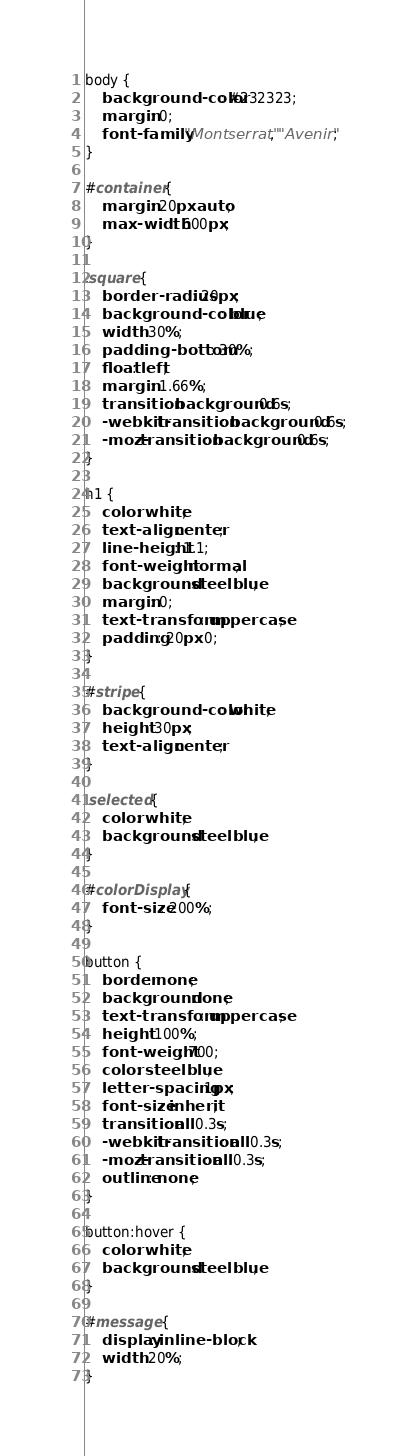Convert code to text. <code><loc_0><loc_0><loc_500><loc_500><_CSS_>body {
    background-color: #232323;
    margin: 0;
    font-family: "Montserrat", "Avenir";
}

#container {
    margin: 20px auto;
    max-width: 600px;
}

.square {
    border-radius: 20px;
    background-color: blue;
    width: 30%;
    padding-bottom: 30%;
    float: left;
    margin: 1.66%;
    transition: background 0.6s;
    -webkit-transition: background 0.6s;
    -moz-transition: background 0.6s;
}

h1 {
    color: white;
    text-align: center;
    line-height: 1.1;
    font-weight: normal;
    background: steelblue;
    margin: 0;
    text-transform: uppercase;
    padding: 20px 0;
}

#stripe {
    background-color: white;
    height: 30px;
    text-align: center;
}

.selected {
    color: white;
    background: steelblue;
}

#colorDisplay {
    font-size: 200%;
}

button {
    border: none;
    background: none;
    text-transform: uppercase;
    height: 100%;
    font-weight: 700;
    color: steelblue;
    letter-spacing: 1px;
    font-size: inherit;
    transition: all 0.3s;
    -webkit-transition: all 0.3s;
    -moz-transition: all 0.3s;
    outline: none;
}

button:hover {
    color: white;
    background: steelblue;
}

#message {
    display: inline-block;
    width: 20%;
}</code> 